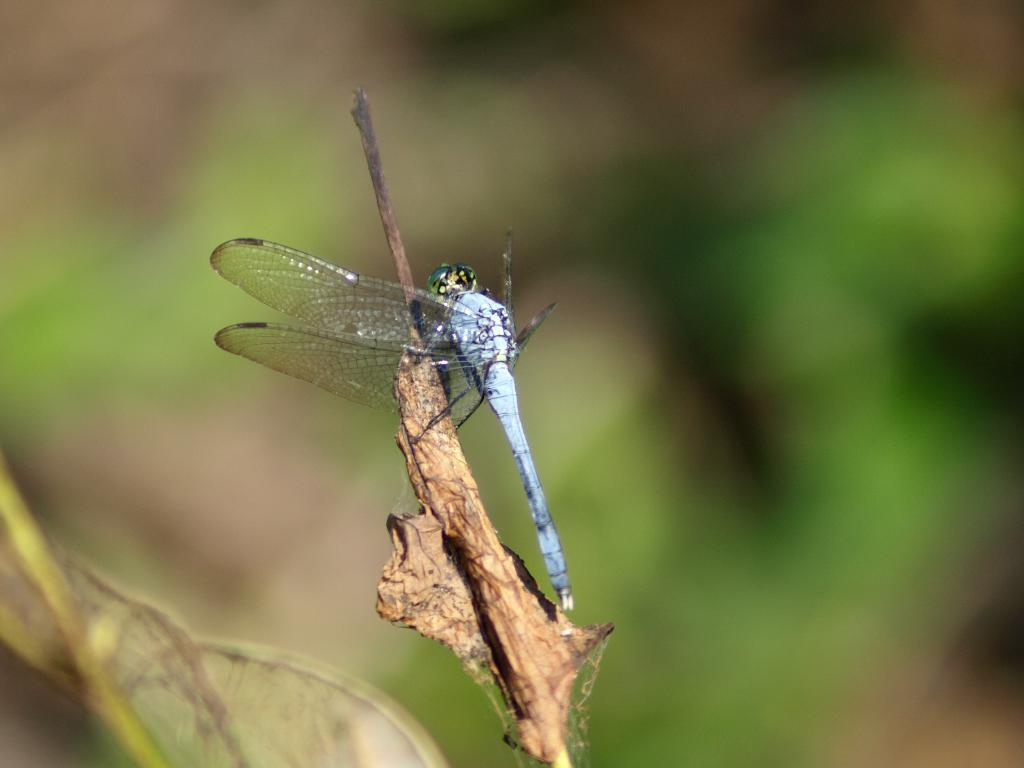What insect is present in the image? There is a dragonfly in the image. What is the dragonfly resting on? The dragonfly is on a dry leaf. Can you describe the background of the image? The background of the image is blurred. What type of disgusting food is being served in the lunchroom in the image? There is no lunchroom or food present in the image; it features a dragonfly on a dry leaf with a blurred background. 